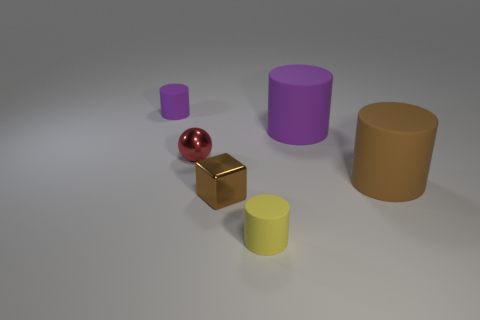Subtract all purple cubes. How many purple cylinders are left? 2 Subtract all yellow cylinders. How many cylinders are left? 3 Add 1 gray metal cylinders. How many objects exist? 7 Subtract all spheres. How many objects are left? 5 Subtract 1 cylinders. How many cylinders are left? 3 Subtract all brown cylinders. How many cylinders are left? 3 Subtract all cyan blocks. Subtract all green balls. How many blocks are left? 1 Subtract all large blue shiny cubes. Subtract all big brown matte cylinders. How many objects are left? 5 Add 1 tiny purple rubber cylinders. How many tiny purple rubber cylinders are left? 2 Add 4 brown matte cylinders. How many brown matte cylinders exist? 5 